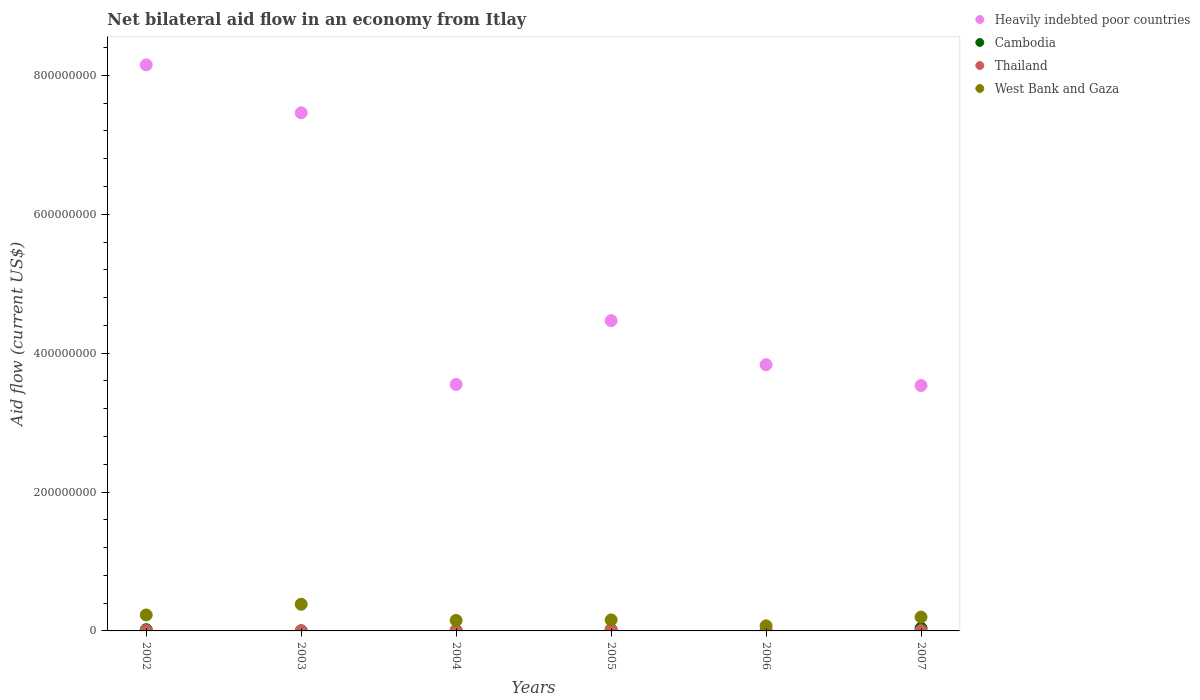How many different coloured dotlines are there?
Give a very brief answer. 4. Is the number of dotlines equal to the number of legend labels?
Ensure brevity in your answer.  Yes. What is the net bilateral aid flow in West Bank and Gaza in 2004?
Give a very brief answer. 1.51e+07. Across all years, what is the maximum net bilateral aid flow in Thailand?
Offer a very short reply. 1.49e+06. In which year was the net bilateral aid flow in Heavily indebted poor countries maximum?
Offer a terse response. 2002. In which year was the net bilateral aid flow in West Bank and Gaza minimum?
Your answer should be very brief. 2006. What is the total net bilateral aid flow in Thailand in the graph?
Your answer should be compact. 4.12e+06. What is the difference between the net bilateral aid flow in Cambodia in 2003 and that in 2006?
Offer a very short reply. -6.00e+04. What is the difference between the net bilateral aid flow in West Bank and Gaza in 2003 and the net bilateral aid flow in Cambodia in 2005?
Ensure brevity in your answer.  3.65e+07. What is the average net bilateral aid flow in West Bank and Gaza per year?
Your response must be concise. 1.99e+07. In the year 2007, what is the difference between the net bilateral aid flow in West Bank and Gaza and net bilateral aid flow in Cambodia?
Keep it short and to the point. 1.60e+07. What is the ratio of the net bilateral aid flow in West Bank and Gaza in 2004 to that in 2006?
Ensure brevity in your answer.  2.07. What is the difference between the highest and the second highest net bilateral aid flow in Heavily indebted poor countries?
Provide a succinct answer. 6.90e+07. What is the difference between the highest and the lowest net bilateral aid flow in Heavily indebted poor countries?
Make the answer very short. 4.62e+08. Is it the case that in every year, the sum of the net bilateral aid flow in Cambodia and net bilateral aid flow in Heavily indebted poor countries  is greater than the sum of net bilateral aid flow in Thailand and net bilateral aid flow in West Bank and Gaza?
Your answer should be very brief. Yes. Is the net bilateral aid flow in Thailand strictly greater than the net bilateral aid flow in Cambodia over the years?
Your response must be concise. No. Is the net bilateral aid flow in Heavily indebted poor countries strictly less than the net bilateral aid flow in Cambodia over the years?
Make the answer very short. No. How many years are there in the graph?
Make the answer very short. 6. Are the values on the major ticks of Y-axis written in scientific E-notation?
Your answer should be very brief. No. Does the graph contain grids?
Your answer should be very brief. No. What is the title of the graph?
Provide a short and direct response. Net bilateral aid flow in an economy from Itlay. What is the label or title of the Y-axis?
Make the answer very short. Aid flow (current US$). What is the Aid flow (current US$) of Heavily indebted poor countries in 2002?
Provide a short and direct response. 8.15e+08. What is the Aid flow (current US$) in Cambodia in 2002?
Ensure brevity in your answer.  1.79e+06. What is the Aid flow (current US$) of Thailand in 2002?
Provide a succinct answer. 5.00e+05. What is the Aid flow (current US$) in West Bank and Gaza in 2002?
Keep it short and to the point. 2.30e+07. What is the Aid flow (current US$) in Heavily indebted poor countries in 2003?
Offer a terse response. 7.46e+08. What is the Aid flow (current US$) in Cambodia in 2003?
Your answer should be very brief. 7.00e+04. What is the Aid flow (current US$) of Thailand in 2003?
Give a very brief answer. 3.10e+05. What is the Aid flow (current US$) of West Bank and Gaza in 2003?
Offer a terse response. 3.84e+07. What is the Aid flow (current US$) in Heavily indebted poor countries in 2004?
Offer a very short reply. 3.55e+08. What is the Aid flow (current US$) of Cambodia in 2004?
Your answer should be very brief. 6.60e+05. What is the Aid flow (current US$) in Thailand in 2004?
Give a very brief answer. 3.20e+05. What is the Aid flow (current US$) of West Bank and Gaza in 2004?
Give a very brief answer. 1.51e+07. What is the Aid flow (current US$) in Heavily indebted poor countries in 2005?
Ensure brevity in your answer.  4.47e+08. What is the Aid flow (current US$) in Cambodia in 2005?
Make the answer very short. 1.92e+06. What is the Aid flow (current US$) in Thailand in 2005?
Give a very brief answer. 1.49e+06. What is the Aid flow (current US$) of West Bank and Gaza in 2005?
Make the answer very short. 1.59e+07. What is the Aid flow (current US$) of Heavily indebted poor countries in 2006?
Keep it short and to the point. 3.83e+08. What is the Aid flow (current US$) of Cambodia in 2006?
Your answer should be compact. 1.30e+05. What is the Aid flow (current US$) in Thailand in 2006?
Ensure brevity in your answer.  1.19e+06. What is the Aid flow (current US$) of West Bank and Gaza in 2006?
Ensure brevity in your answer.  7.32e+06. What is the Aid flow (current US$) of Heavily indebted poor countries in 2007?
Your answer should be very brief. 3.53e+08. What is the Aid flow (current US$) in Cambodia in 2007?
Offer a very short reply. 3.94e+06. What is the Aid flow (current US$) of Thailand in 2007?
Offer a terse response. 3.10e+05. What is the Aid flow (current US$) of West Bank and Gaza in 2007?
Ensure brevity in your answer.  1.99e+07. Across all years, what is the maximum Aid flow (current US$) of Heavily indebted poor countries?
Ensure brevity in your answer.  8.15e+08. Across all years, what is the maximum Aid flow (current US$) of Cambodia?
Offer a very short reply. 3.94e+06. Across all years, what is the maximum Aid flow (current US$) of Thailand?
Your answer should be compact. 1.49e+06. Across all years, what is the maximum Aid flow (current US$) of West Bank and Gaza?
Your response must be concise. 3.84e+07. Across all years, what is the minimum Aid flow (current US$) in Heavily indebted poor countries?
Give a very brief answer. 3.53e+08. Across all years, what is the minimum Aid flow (current US$) in Thailand?
Ensure brevity in your answer.  3.10e+05. Across all years, what is the minimum Aid flow (current US$) in West Bank and Gaza?
Give a very brief answer. 7.32e+06. What is the total Aid flow (current US$) of Heavily indebted poor countries in the graph?
Make the answer very short. 3.10e+09. What is the total Aid flow (current US$) in Cambodia in the graph?
Offer a terse response. 8.51e+06. What is the total Aid flow (current US$) of Thailand in the graph?
Your answer should be very brief. 4.12e+06. What is the total Aid flow (current US$) in West Bank and Gaza in the graph?
Keep it short and to the point. 1.20e+08. What is the difference between the Aid flow (current US$) in Heavily indebted poor countries in 2002 and that in 2003?
Offer a very short reply. 6.90e+07. What is the difference between the Aid flow (current US$) of Cambodia in 2002 and that in 2003?
Make the answer very short. 1.72e+06. What is the difference between the Aid flow (current US$) in West Bank and Gaza in 2002 and that in 2003?
Make the answer very short. -1.54e+07. What is the difference between the Aid flow (current US$) in Heavily indebted poor countries in 2002 and that in 2004?
Ensure brevity in your answer.  4.60e+08. What is the difference between the Aid flow (current US$) of Cambodia in 2002 and that in 2004?
Make the answer very short. 1.13e+06. What is the difference between the Aid flow (current US$) of Thailand in 2002 and that in 2004?
Offer a terse response. 1.80e+05. What is the difference between the Aid flow (current US$) of West Bank and Gaza in 2002 and that in 2004?
Make the answer very short. 7.87e+06. What is the difference between the Aid flow (current US$) of Heavily indebted poor countries in 2002 and that in 2005?
Ensure brevity in your answer.  3.68e+08. What is the difference between the Aid flow (current US$) in Thailand in 2002 and that in 2005?
Keep it short and to the point. -9.90e+05. What is the difference between the Aid flow (current US$) of West Bank and Gaza in 2002 and that in 2005?
Your response must be concise. 7.10e+06. What is the difference between the Aid flow (current US$) of Heavily indebted poor countries in 2002 and that in 2006?
Keep it short and to the point. 4.32e+08. What is the difference between the Aid flow (current US$) in Cambodia in 2002 and that in 2006?
Give a very brief answer. 1.66e+06. What is the difference between the Aid flow (current US$) in Thailand in 2002 and that in 2006?
Offer a terse response. -6.90e+05. What is the difference between the Aid flow (current US$) of West Bank and Gaza in 2002 and that in 2006?
Provide a succinct answer. 1.57e+07. What is the difference between the Aid flow (current US$) in Heavily indebted poor countries in 2002 and that in 2007?
Provide a short and direct response. 4.62e+08. What is the difference between the Aid flow (current US$) of Cambodia in 2002 and that in 2007?
Offer a very short reply. -2.15e+06. What is the difference between the Aid flow (current US$) of West Bank and Gaza in 2002 and that in 2007?
Keep it short and to the point. 3.08e+06. What is the difference between the Aid flow (current US$) in Heavily indebted poor countries in 2003 and that in 2004?
Make the answer very short. 3.91e+08. What is the difference between the Aid flow (current US$) of Cambodia in 2003 and that in 2004?
Your answer should be compact. -5.90e+05. What is the difference between the Aid flow (current US$) of Thailand in 2003 and that in 2004?
Offer a terse response. -10000. What is the difference between the Aid flow (current US$) of West Bank and Gaza in 2003 and that in 2004?
Offer a very short reply. 2.33e+07. What is the difference between the Aid flow (current US$) of Heavily indebted poor countries in 2003 and that in 2005?
Provide a succinct answer. 2.99e+08. What is the difference between the Aid flow (current US$) of Cambodia in 2003 and that in 2005?
Ensure brevity in your answer.  -1.85e+06. What is the difference between the Aid flow (current US$) of Thailand in 2003 and that in 2005?
Provide a succinct answer. -1.18e+06. What is the difference between the Aid flow (current US$) in West Bank and Gaza in 2003 and that in 2005?
Provide a succinct answer. 2.25e+07. What is the difference between the Aid flow (current US$) in Heavily indebted poor countries in 2003 and that in 2006?
Ensure brevity in your answer.  3.63e+08. What is the difference between the Aid flow (current US$) in Thailand in 2003 and that in 2006?
Give a very brief answer. -8.80e+05. What is the difference between the Aid flow (current US$) in West Bank and Gaza in 2003 and that in 2006?
Provide a short and direct response. 3.11e+07. What is the difference between the Aid flow (current US$) of Heavily indebted poor countries in 2003 and that in 2007?
Offer a terse response. 3.93e+08. What is the difference between the Aid flow (current US$) of Cambodia in 2003 and that in 2007?
Keep it short and to the point. -3.87e+06. What is the difference between the Aid flow (current US$) of Thailand in 2003 and that in 2007?
Make the answer very short. 0. What is the difference between the Aid flow (current US$) of West Bank and Gaza in 2003 and that in 2007?
Ensure brevity in your answer.  1.85e+07. What is the difference between the Aid flow (current US$) of Heavily indebted poor countries in 2004 and that in 2005?
Offer a terse response. -9.18e+07. What is the difference between the Aid flow (current US$) of Cambodia in 2004 and that in 2005?
Offer a terse response. -1.26e+06. What is the difference between the Aid flow (current US$) of Thailand in 2004 and that in 2005?
Ensure brevity in your answer.  -1.17e+06. What is the difference between the Aid flow (current US$) in West Bank and Gaza in 2004 and that in 2005?
Offer a terse response. -7.70e+05. What is the difference between the Aid flow (current US$) of Heavily indebted poor countries in 2004 and that in 2006?
Offer a terse response. -2.84e+07. What is the difference between the Aid flow (current US$) in Cambodia in 2004 and that in 2006?
Offer a very short reply. 5.30e+05. What is the difference between the Aid flow (current US$) in Thailand in 2004 and that in 2006?
Your answer should be very brief. -8.70e+05. What is the difference between the Aid flow (current US$) of West Bank and Gaza in 2004 and that in 2006?
Offer a very short reply. 7.80e+06. What is the difference between the Aid flow (current US$) in Heavily indebted poor countries in 2004 and that in 2007?
Your answer should be very brief. 1.54e+06. What is the difference between the Aid flow (current US$) in Cambodia in 2004 and that in 2007?
Provide a short and direct response. -3.28e+06. What is the difference between the Aid flow (current US$) in West Bank and Gaza in 2004 and that in 2007?
Keep it short and to the point. -4.79e+06. What is the difference between the Aid flow (current US$) in Heavily indebted poor countries in 2005 and that in 2006?
Offer a terse response. 6.35e+07. What is the difference between the Aid flow (current US$) in Cambodia in 2005 and that in 2006?
Offer a very short reply. 1.79e+06. What is the difference between the Aid flow (current US$) of West Bank and Gaza in 2005 and that in 2006?
Give a very brief answer. 8.57e+06. What is the difference between the Aid flow (current US$) of Heavily indebted poor countries in 2005 and that in 2007?
Ensure brevity in your answer.  9.34e+07. What is the difference between the Aid flow (current US$) of Cambodia in 2005 and that in 2007?
Your answer should be very brief. -2.02e+06. What is the difference between the Aid flow (current US$) of Thailand in 2005 and that in 2007?
Provide a short and direct response. 1.18e+06. What is the difference between the Aid flow (current US$) in West Bank and Gaza in 2005 and that in 2007?
Offer a very short reply. -4.02e+06. What is the difference between the Aid flow (current US$) of Heavily indebted poor countries in 2006 and that in 2007?
Give a very brief answer. 2.99e+07. What is the difference between the Aid flow (current US$) in Cambodia in 2006 and that in 2007?
Your response must be concise. -3.81e+06. What is the difference between the Aid flow (current US$) of Thailand in 2006 and that in 2007?
Ensure brevity in your answer.  8.80e+05. What is the difference between the Aid flow (current US$) of West Bank and Gaza in 2006 and that in 2007?
Your answer should be compact. -1.26e+07. What is the difference between the Aid flow (current US$) in Heavily indebted poor countries in 2002 and the Aid flow (current US$) in Cambodia in 2003?
Make the answer very short. 8.15e+08. What is the difference between the Aid flow (current US$) of Heavily indebted poor countries in 2002 and the Aid flow (current US$) of Thailand in 2003?
Give a very brief answer. 8.15e+08. What is the difference between the Aid flow (current US$) in Heavily indebted poor countries in 2002 and the Aid flow (current US$) in West Bank and Gaza in 2003?
Provide a short and direct response. 7.77e+08. What is the difference between the Aid flow (current US$) of Cambodia in 2002 and the Aid flow (current US$) of Thailand in 2003?
Provide a short and direct response. 1.48e+06. What is the difference between the Aid flow (current US$) of Cambodia in 2002 and the Aid flow (current US$) of West Bank and Gaza in 2003?
Provide a succinct answer. -3.66e+07. What is the difference between the Aid flow (current US$) of Thailand in 2002 and the Aid flow (current US$) of West Bank and Gaza in 2003?
Offer a very short reply. -3.79e+07. What is the difference between the Aid flow (current US$) of Heavily indebted poor countries in 2002 and the Aid flow (current US$) of Cambodia in 2004?
Your answer should be compact. 8.14e+08. What is the difference between the Aid flow (current US$) in Heavily indebted poor countries in 2002 and the Aid flow (current US$) in Thailand in 2004?
Make the answer very short. 8.15e+08. What is the difference between the Aid flow (current US$) of Heavily indebted poor countries in 2002 and the Aid flow (current US$) of West Bank and Gaza in 2004?
Your answer should be very brief. 8.00e+08. What is the difference between the Aid flow (current US$) in Cambodia in 2002 and the Aid flow (current US$) in Thailand in 2004?
Make the answer very short. 1.47e+06. What is the difference between the Aid flow (current US$) in Cambodia in 2002 and the Aid flow (current US$) in West Bank and Gaza in 2004?
Ensure brevity in your answer.  -1.33e+07. What is the difference between the Aid flow (current US$) of Thailand in 2002 and the Aid flow (current US$) of West Bank and Gaza in 2004?
Your answer should be compact. -1.46e+07. What is the difference between the Aid flow (current US$) in Heavily indebted poor countries in 2002 and the Aid flow (current US$) in Cambodia in 2005?
Offer a terse response. 8.13e+08. What is the difference between the Aid flow (current US$) of Heavily indebted poor countries in 2002 and the Aid flow (current US$) of Thailand in 2005?
Make the answer very short. 8.14e+08. What is the difference between the Aid flow (current US$) of Heavily indebted poor countries in 2002 and the Aid flow (current US$) of West Bank and Gaza in 2005?
Your answer should be very brief. 7.99e+08. What is the difference between the Aid flow (current US$) of Cambodia in 2002 and the Aid flow (current US$) of Thailand in 2005?
Offer a very short reply. 3.00e+05. What is the difference between the Aid flow (current US$) of Cambodia in 2002 and the Aid flow (current US$) of West Bank and Gaza in 2005?
Provide a short and direct response. -1.41e+07. What is the difference between the Aid flow (current US$) of Thailand in 2002 and the Aid flow (current US$) of West Bank and Gaza in 2005?
Provide a short and direct response. -1.54e+07. What is the difference between the Aid flow (current US$) in Heavily indebted poor countries in 2002 and the Aid flow (current US$) in Cambodia in 2006?
Your answer should be compact. 8.15e+08. What is the difference between the Aid flow (current US$) of Heavily indebted poor countries in 2002 and the Aid flow (current US$) of Thailand in 2006?
Provide a short and direct response. 8.14e+08. What is the difference between the Aid flow (current US$) in Heavily indebted poor countries in 2002 and the Aid flow (current US$) in West Bank and Gaza in 2006?
Ensure brevity in your answer.  8.08e+08. What is the difference between the Aid flow (current US$) of Cambodia in 2002 and the Aid flow (current US$) of West Bank and Gaza in 2006?
Offer a terse response. -5.53e+06. What is the difference between the Aid flow (current US$) in Thailand in 2002 and the Aid flow (current US$) in West Bank and Gaza in 2006?
Make the answer very short. -6.82e+06. What is the difference between the Aid flow (current US$) in Heavily indebted poor countries in 2002 and the Aid flow (current US$) in Cambodia in 2007?
Make the answer very short. 8.11e+08. What is the difference between the Aid flow (current US$) in Heavily indebted poor countries in 2002 and the Aid flow (current US$) in Thailand in 2007?
Give a very brief answer. 8.15e+08. What is the difference between the Aid flow (current US$) in Heavily indebted poor countries in 2002 and the Aid flow (current US$) in West Bank and Gaza in 2007?
Provide a short and direct response. 7.95e+08. What is the difference between the Aid flow (current US$) in Cambodia in 2002 and the Aid flow (current US$) in Thailand in 2007?
Give a very brief answer. 1.48e+06. What is the difference between the Aid flow (current US$) of Cambodia in 2002 and the Aid flow (current US$) of West Bank and Gaza in 2007?
Make the answer very short. -1.81e+07. What is the difference between the Aid flow (current US$) of Thailand in 2002 and the Aid flow (current US$) of West Bank and Gaza in 2007?
Your response must be concise. -1.94e+07. What is the difference between the Aid flow (current US$) in Heavily indebted poor countries in 2003 and the Aid flow (current US$) in Cambodia in 2004?
Keep it short and to the point. 7.45e+08. What is the difference between the Aid flow (current US$) of Heavily indebted poor countries in 2003 and the Aid flow (current US$) of Thailand in 2004?
Make the answer very short. 7.46e+08. What is the difference between the Aid flow (current US$) of Heavily indebted poor countries in 2003 and the Aid flow (current US$) of West Bank and Gaza in 2004?
Make the answer very short. 7.31e+08. What is the difference between the Aid flow (current US$) in Cambodia in 2003 and the Aid flow (current US$) in West Bank and Gaza in 2004?
Offer a terse response. -1.50e+07. What is the difference between the Aid flow (current US$) in Thailand in 2003 and the Aid flow (current US$) in West Bank and Gaza in 2004?
Provide a short and direct response. -1.48e+07. What is the difference between the Aid flow (current US$) in Heavily indebted poor countries in 2003 and the Aid flow (current US$) in Cambodia in 2005?
Provide a short and direct response. 7.44e+08. What is the difference between the Aid flow (current US$) in Heavily indebted poor countries in 2003 and the Aid flow (current US$) in Thailand in 2005?
Provide a succinct answer. 7.45e+08. What is the difference between the Aid flow (current US$) of Heavily indebted poor countries in 2003 and the Aid flow (current US$) of West Bank and Gaza in 2005?
Your response must be concise. 7.30e+08. What is the difference between the Aid flow (current US$) in Cambodia in 2003 and the Aid flow (current US$) in Thailand in 2005?
Your response must be concise. -1.42e+06. What is the difference between the Aid flow (current US$) in Cambodia in 2003 and the Aid flow (current US$) in West Bank and Gaza in 2005?
Offer a very short reply. -1.58e+07. What is the difference between the Aid flow (current US$) of Thailand in 2003 and the Aid flow (current US$) of West Bank and Gaza in 2005?
Provide a short and direct response. -1.56e+07. What is the difference between the Aid flow (current US$) of Heavily indebted poor countries in 2003 and the Aid flow (current US$) of Cambodia in 2006?
Your response must be concise. 7.46e+08. What is the difference between the Aid flow (current US$) of Heavily indebted poor countries in 2003 and the Aid flow (current US$) of Thailand in 2006?
Make the answer very short. 7.45e+08. What is the difference between the Aid flow (current US$) of Heavily indebted poor countries in 2003 and the Aid flow (current US$) of West Bank and Gaza in 2006?
Offer a very short reply. 7.39e+08. What is the difference between the Aid flow (current US$) of Cambodia in 2003 and the Aid flow (current US$) of Thailand in 2006?
Your answer should be compact. -1.12e+06. What is the difference between the Aid flow (current US$) in Cambodia in 2003 and the Aid flow (current US$) in West Bank and Gaza in 2006?
Your answer should be very brief. -7.25e+06. What is the difference between the Aid flow (current US$) of Thailand in 2003 and the Aid flow (current US$) of West Bank and Gaza in 2006?
Give a very brief answer. -7.01e+06. What is the difference between the Aid flow (current US$) of Heavily indebted poor countries in 2003 and the Aid flow (current US$) of Cambodia in 2007?
Provide a short and direct response. 7.42e+08. What is the difference between the Aid flow (current US$) of Heavily indebted poor countries in 2003 and the Aid flow (current US$) of Thailand in 2007?
Give a very brief answer. 7.46e+08. What is the difference between the Aid flow (current US$) of Heavily indebted poor countries in 2003 and the Aid flow (current US$) of West Bank and Gaza in 2007?
Your answer should be very brief. 7.26e+08. What is the difference between the Aid flow (current US$) in Cambodia in 2003 and the Aid flow (current US$) in Thailand in 2007?
Your response must be concise. -2.40e+05. What is the difference between the Aid flow (current US$) of Cambodia in 2003 and the Aid flow (current US$) of West Bank and Gaza in 2007?
Ensure brevity in your answer.  -1.98e+07. What is the difference between the Aid flow (current US$) of Thailand in 2003 and the Aid flow (current US$) of West Bank and Gaza in 2007?
Your response must be concise. -1.96e+07. What is the difference between the Aid flow (current US$) in Heavily indebted poor countries in 2004 and the Aid flow (current US$) in Cambodia in 2005?
Keep it short and to the point. 3.53e+08. What is the difference between the Aid flow (current US$) in Heavily indebted poor countries in 2004 and the Aid flow (current US$) in Thailand in 2005?
Offer a very short reply. 3.53e+08. What is the difference between the Aid flow (current US$) in Heavily indebted poor countries in 2004 and the Aid flow (current US$) in West Bank and Gaza in 2005?
Make the answer very short. 3.39e+08. What is the difference between the Aid flow (current US$) in Cambodia in 2004 and the Aid flow (current US$) in Thailand in 2005?
Your answer should be very brief. -8.30e+05. What is the difference between the Aid flow (current US$) of Cambodia in 2004 and the Aid flow (current US$) of West Bank and Gaza in 2005?
Offer a very short reply. -1.52e+07. What is the difference between the Aid flow (current US$) of Thailand in 2004 and the Aid flow (current US$) of West Bank and Gaza in 2005?
Make the answer very short. -1.56e+07. What is the difference between the Aid flow (current US$) of Heavily indebted poor countries in 2004 and the Aid flow (current US$) of Cambodia in 2006?
Provide a succinct answer. 3.55e+08. What is the difference between the Aid flow (current US$) of Heavily indebted poor countries in 2004 and the Aid flow (current US$) of Thailand in 2006?
Give a very brief answer. 3.54e+08. What is the difference between the Aid flow (current US$) of Heavily indebted poor countries in 2004 and the Aid flow (current US$) of West Bank and Gaza in 2006?
Your answer should be compact. 3.48e+08. What is the difference between the Aid flow (current US$) in Cambodia in 2004 and the Aid flow (current US$) in Thailand in 2006?
Ensure brevity in your answer.  -5.30e+05. What is the difference between the Aid flow (current US$) of Cambodia in 2004 and the Aid flow (current US$) of West Bank and Gaza in 2006?
Offer a very short reply. -6.66e+06. What is the difference between the Aid flow (current US$) in Thailand in 2004 and the Aid flow (current US$) in West Bank and Gaza in 2006?
Provide a succinct answer. -7.00e+06. What is the difference between the Aid flow (current US$) in Heavily indebted poor countries in 2004 and the Aid flow (current US$) in Cambodia in 2007?
Provide a succinct answer. 3.51e+08. What is the difference between the Aid flow (current US$) in Heavily indebted poor countries in 2004 and the Aid flow (current US$) in Thailand in 2007?
Provide a short and direct response. 3.55e+08. What is the difference between the Aid flow (current US$) of Heavily indebted poor countries in 2004 and the Aid flow (current US$) of West Bank and Gaza in 2007?
Your answer should be compact. 3.35e+08. What is the difference between the Aid flow (current US$) in Cambodia in 2004 and the Aid flow (current US$) in West Bank and Gaza in 2007?
Your answer should be compact. -1.92e+07. What is the difference between the Aid flow (current US$) of Thailand in 2004 and the Aid flow (current US$) of West Bank and Gaza in 2007?
Keep it short and to the point. -1.96e+07. What is the difference between the Aid flow (current US$) in Heavily indebted poor countries in 2005 and the Aid flow (current US$) in Cambodia in 2006?
Offer a terse response. 4.47e+08. What is the difference between the Aid flow (current US$) of Heavily indebted poor countries in 2005 and the Aid flow (current US$) of Thailand in 2006?
Your answer should be compact. 4.46e+08. What is the difference between the Aid flow (current US$) in Heavily indebted poor countries in 2005 and the Aid flow (current US$) in West Bank and Gaza in 2006?
Your answer should be compact. 4.39e+08. What is the difference between the Aid flow (current US$) in Cambodia in 2005 and the Aid flow (current US$) in Thailand in 2006?
Your response must be concise. 7.30e+05. What is the difference between the Aid flow (current US$) of Cambodia in 2005 and the Aid flow (current US$) of West Bank and Gaza in 2006?
Ensure brevity in your answer.  -5.40e+06. What is the difference between the Aid flow (current US$) in Thailand in 2005 and the Aid flow (current US$) in West Bank and Gaza in 2006?
Ensure brevity in your answer.  -5.83e+06. What is the difference between the Aid flow (current US$) of Heavily indebted poor countries in 2005 and the Aid flow (current US$) of Cambodia in 2007?
Your answer should be very brief. 4.43e+08. What is the difference between the Aid flow (current US$) of Heavily indebted poor countries in 2005 and the Aid flow (current US$) of Thailand in 2007?
Give a very brief answer. 4.46e+08. What is the difference between the Aid flow (current US$) in Heavily indebted poor countries in 2005 and the Aid flow (current US$) in West Bank and Gaza in 2007?
Your response must be concise. 4.27e+08. What is the difference between the Aid flow (current US$) in Cambodia in 2005 and the Aid flow (current US$) in Thailand in 2007?
Provide a short and direct response. 1.61e+06. What is the difference between the Aid flow (current US$) in Cambodia in 2005 and the Aid flow (current US$) in West Bank and Gaza in 2007?
Ensure brevity in your answer.  -1.80e+07. What is the difference between the Aid flow (current US$) of Thailand in 2005 and the Aid flow (current US$) of West Bank and Gaza in 2007?
Your answer should be compact. -1.84e+07. What is the difference between the Aid flow (current US$) in Heavily indebted poor countries in 2006 and the Aid flow (current US$) in Cambodia in 2007?
Provide a succinct answer. 3.79e+08. What is the difference between the Aid flow (current US$) of Heavily indebted poor countries in 2006 and the Aid flow (current US$) of Thailand in 2007?
Your response must be concise. 3.83e+08. What is the difference between the Aid flow (current US$) in Heavily indebted poor countries in 2006 and the Aid flow (current US$) in West Bank and Gaza in 2007?
Keep it short and to the point. 3.63e+08. What is the difference between the Aid flow (current US$) in Cambodia in 2006 and the Aid flow (current US$) in Thailand in 2007?
Your answer should be very brief. -1.80e+05. What is the difference between the Aid flow (current US$) of Cambodia in 2006 and the Aid flow (current US$) of West Bank and Gaza in 2007?
Give a very brief answer. -1.98e+07. What is the difference between the Aid flow (current US$) of Thailand in 2006 and the Aid flow (current US$) of West Bank and Gaza in 2007?
Keep it short and to the point. -1.87e+07. What is the average Aid flow (current US$) in Heavily indebted poor countries per year?
Provide a short and direct response. 5.17e+08. What is the average Aid flow (current US$) in Cambodia per year?
Your answer should be compact. 1.42e+06. What is the average Aid flow (current US$) in Thailand per year?
Your answer should be compact. 6.87e+05. What is the average Aid flow (current US$) of West Bank and Gaza per year?
Give a very brief answer. 1.99e+07. In the year 2002, what is the difference between the Aid flow (current US$) in Heavily indebted poor countries and Aid flow (current US$) in Cambodia?
Provide a succinct answer. 8.13e+08. In the year 2002, what is the difference between the Aid flow (current US$) in Heavily indebted poor countries and Aid flow (current US$) in Thailand?
Provide a succinct answer. 8.15e+08. In the year 2002, what is the difference between the Aid flow (current US$) of Heavily indebted poor countries and Aid flow (current US$) of West Bank and Gaza?
Your response must be concise. 7.92e+08. In the year 2002, what is the difference between the Aid flow (current US$) in Cambodia and Aid flow (current US$) in Thailand?
Give a very brief answer. 1.29e+06. In the year 2002, what is the difference between the Aid flow (current US$) in Cambodia and Aid flow (current US$) in West Bank and Gaza?
Your answer should be compact. -2.12e+07. In the year 2002, what is the difference between the Aid flow (current US$) of Thailand and Aid flow (current US$) of West Bank and Gaza?
Give a very brief answer. -2.25e+07. In the year 2003, what is the difference between the Aid flow (current US$) of Heavily indebted poor countries and Aid flow (current US$) of Cambodia?
Offer a very short reply. 7.46e+08. In the year 2003, what is the difference between the Aid flow (current US$) in Heavily indebted poor countries and Aid flow (current US$) in Thailand?
Ensure brevity in your answer.  7.46e+08. In the year 2003, what is the difference between the Aid flow (current US$) in Heavily indebted poor countries and Aid flow (current US$) in West Bank and Gaza?
Provide a succinct answer. 7.08e+08. In the year 2003, what is the difference between the Aid flow (current US$) in Cambodia and Aid flow (current US$) in Thailand?
Provide a short and direct response. -2.40e+05. In the year 2003, what is the difference between the Aid flow (current US$) in Cambodia and Aid flow (current US$) in West Bank and Gaza?
Your answer should be compact. -3.83e+07. In the year 2003, what is the difference between the Aid flow (current US$) in Thailand and Aid flow (current US$) in West Bank and Gaza?
Provide a succinct answer. -3.81e+07. In the year 2004, what is the difference between the Aid flow (current US$) in Heavily indebted poor countries and Aid flow (current US$) in Cambodia?
Your answer should be very brief. 3.54e+08. In the year 2004, what is the difference between the Aid flow (current US$) of Heavily indebted poor countries and Aid flow (current US$) of Thailand?
Your answer should be compact. 3.55e+08. In the year 2004, what is the difference between the Aid flow (current US$) of Heavily indebted poor countries and Aid flow (current US$) of West Bank and Gaza?
Offer a very short reply. 3.40e+08. In the year 2004, what is the difference between the Aid flow (current US$) in Cambodia and Aid flow (current US$) in West Bank and Gaza?
Offer a terse response. -1.45e+07. In the year 2004, what is the difference between the Aid flow (current US$) in Thailand and Aid flow (current US$) in West Bank and Gaza?
Offer a terse response. -1.48e+07. In the year 2005, what is the difference between the Aid flow (current US$) of Heavily indebted poor countries and Aid flow (current US$) of Cambodia?
Offer a terse response. 4.45e+08. In the year 2005, what is the difference between the Aid flow (current US$) in Heavily indebted poor countries and Aid flow (current US$) in Thailand?
Offer a terse response. 4.45e+08. In the year 2005, what is the difference between the Aid flow (current US$) in Heavily indebted poor countries and Aid flow (current US$) in West Bank and Gaza?
Offer a terse response. 4.31e+08. In the year 2005, what is the difference between the Aid flow (current US$) in Cambodia and Aid flow (current US$) in West Bank and Gaza?
Offer a terse response. -1.40e+07. In the year 2005, what is the difference between the Aid flow (current US$) of Thailand and Aid flow (current US$) of West Bank and Gaza?
Your answer should be compact. -1.44e+07. In the year 2006, what is the difference between the Aid flow (current US$) of Heavily indebted poor countries and Aid flow (current US$) of Cambodia?
Provide a short and direct response. 3.83e+08. In the year 2006, what is the difference between the Aid flow (current US$) in Heavily indebted poor countries and Aid flow (current US$) in Thailand?
Your answer should be very brief. 3.82e+08. In the year 2006, what is the difference between the Aid flow (current US$) in Heavily indebted poor countries and Aid flow (current US$) in West Bank and Gaza?
Provide a succinct answer. 3.76e+08. In the year 2006, what is the difference between the Aid flow (current US$) of Cambodia and Aid flow (current US$) of Thailand?
Offer a terse response. -1.06e+06. In the year 2006, what is the difference between the Aid flow (current US$) of Cambodia and Aid flow (current US$) of West Bank and Gaza?
Your response must be concise. -7.19e+06. In the year 2006, what is the difference between the Aid flow (current US$) of Thailand and Aid flow (current US$) of West Bank and Gaza?
Provide a short and direct response. -6.13e+06. In the year 2007, what is the difference between the Aid flow (current US$) of Heavily indebted poor countries and Aid flow (current US$) of Cambodia?
Give a very brief answer. 3.49e+08. In the year 2007, what is the difference between the Aid flow (current US$) in Heavily indebted poor countries and Aid flow (current US$) in Thailand?
Offer a terse response. 3.53e+08. In the year 2007, what is the difference between the Aid flow (current US$) of Heavily indebted poor countries and Aid flow (current US$) of West Bank and Gaza?
Offer a terse response. 3.33e+08. In the year 2007, what is the difference between the Aid flow (current US$) of Cambodia and Aid flow (current US$) of Thailand?
Provide a short and direct response. 3.63e+06. In the year 2007, what is the difference between the Aid flow (current US$) of Cambodia and Aid flow (current US$) of West Bank and Gaza?
Make the answer very short. -1.60e+07. In the year 2007, what is the difference between the Aid flow (current US$) of Thailand and Aid flow (current US$) of West Bank and Gaza?
Make the answer very short. -1.96e+07. What is the ratio of the Aid flow (current US$) in Heavily indebted poor countries in 2002 to that in 2003?
Offer a very short reply. 1.09. What is the ratio of the Aid flow (current US$) in Cambodia in 2002 to that in 2003?
Provide a short and direct response. 25.57. What is the ratio of the Aid flow (current US$) of Thailand in 2002 to that in 2003?
Provide a succinct answer. 1.61. What is the ratio of the Aid flow (current US$) in West Bank and Gaza in 2002 to that in 2003?
Offer a terse response. 0.6. What is the ratio of the Aid flow (current US$) of Heavily indebted poor countries in 2002 to that in 2004?
Give a very brief answer. 2.3. What is the ratio of the Aid flow (current US$) in Cambodia in 2002 to that in 2004?
Provide a short and direct response. 2.71. What is the ratio of the Aid flow (current US$) of Thailand in 2002 to that in 2004?
Ensure brevity in your answer.  1.56. What is the ratio of the Aid flow (current US$) in West Bank and Gaza in 2002 to that in 2004?
Make the answer very short. 1.52. What is the ratio of the Aid flow (current US$) of Heavily indebted poor countries in 2002 to that in 2005?
Make the answer very short. 1.82. What is the ratio of the Aid flow (current US$) of Cambodia in 2002 to that in 2005?
Ensure brevity in your answer.  0.93. What is the ratio of the Aid flow (current US$) of Thailand in 2002 to that in 2005?
Offer a very short reply. 0.34. What is the ratio of the Aid flow (current US$) in West Bank and Gaza in 2002 to that in 2005?
Provide a succinct answer. 1.45. What is the ratio of the Aid flow (current US$) in Heavily indebted poor countries in 2002 to that in 2006?
Offer a very short reply. 2.13. What is the ratio of the Aid flow (current US$) in Cambodia in 2002 to that in 2006?
Provide a succinct answer. 13.77. What is the ratio of the Aid flow (current US$) of Thailand in 2002 to that in 2006?
Your answer should be compact. 0.42. What is the ratio of the Aid flow (current US$) of West Bank and Gaza in 2002 to that in 2006?
Keep it short and to the point. 3.14. What is the ratio of the Aid flow (current US$) in Heavily indebted poor countries in 2002 to that in 2007?
Your answer should be compact. 2.31. What is the ratio of the Aid flow (current US$) of Cambodia in 2002 to that in 2007?
Give a very brief answer. 0.45. What is the ratio of the Aid flow (current US$) of Thailand in 2002 to that in 2007?
Give a very brief answer. 1.61. What is the ratio of the Aid flow (current US$) in West Bank and Gaza in 2002 to that in 2007?
Offer a terse response. 1.15. What is the ratio of the Aid flow (current US$) of Heavily indebted poor countries in 2003 to that in 2004?
Provide a succinct answer. 2.1. What is the ratio of the Aid flow (current US$) in Cambodia in 2003 to that in 2004?
Make the answer very short. 0.11. What is the ratio of the Aid flow (current US$) in Thailand in 2003 to that in 2004?
Give a very brief answer. 0.97. What is the ratio of the Aid flow (current US$) of West Bank and Gaza in 2003 to that in 2004?
Keep it short and to the point. 2.54. What is the ratio of the Aid flow (current US$) of Heavily indebted poor countries in 2003 to that in 2005?
Your answer should be very brief. 1.67. What is the ratio of the Aid flow (current US$) of Cambodia in 2003 to that in 2005?
Provide a short and direct response. 0.04. What is the ratio of the Aid flow (current US$) in Thailand in 2003 to that in 2005?
Offer a terse response. 0.21. What is the ratio of the Aid flow (current US$) in West Bank and Gaza in 2003 to that in 2005?
Ensure brevity in your answer.  2.42. What is the ratio of the Aid flow (current US$) in Heavily indebted poor countries in 2003 to that in 2006?
Give a very brief answer. 1.95. What is the ratio of the Aid flow (current US$) in Cambodia in 2003 to that in 2006?
Offer a very short reply. 0.54. What is the ratio of the Aid flow (current US$) of Thailand in 2003 to that in 2006?
Your response must be concise. 0.26. What is the ratio of the Aid flow (current US$) of West Bank and Gaza in 2003 to that in 2006?
Ensure brevity in your answer.  5.24. What is the ratio of the Aid flow (current US$) in Heavily indebted poor countries in 2003 to that in 2007?
Provide a short and direct response. 2.11. What is the ratio of the Aid flow (current US$) in Cambodia in 2003 to that in 2007?
Ensure brevity in your answer.  0.02. What is the ratio of the Aid flow (current US$) in West Bank and Gaza in 2003 to that in 2007?
Your answer should be compact. 1.93. What is the ratio of the Aid flow (current US$) in Heavily indebted poor countries in 2004 to that in 2005?
Keep it short and to the point. 0.79. What is the ratio of the Aid flow (current US$) in Cambodia in 2004 to that in 2005?
Make the answer very short. 0.34. What is the ratio of the Aid flow (current US$) in Thailand in 2004 to that in 2005?
Offer a terse response. 0.21. What is the ratio of the Aid flow (current US$) in West Bank and Gaza in 2004 to that in 2005?
Make the answer very short. 0.95. What is the ratio of the Aid flow (current US$) in Heavily indebted poor countries in 2004 to that in 2006?
Your answer should be compact. 0.93. What is the ratio of the Aid flow (current US$) of Cambodia in 2004 to that in 2006?
Your answer should be very brief. 5.08. What is the ratio of the Aid flow (current US$) of Thailand in 2004 to that in 2006?
Provide a succinct answer. 0.27. What is the ratio of the Aid flow (current US$) of West Bank and Gaza in 2004 to that in 2006?
Keep it short and to the point. 2.07. What is the ratio of the Aid flow (current US$) of Heavily indebted poor countries in 2004 to that in 2007?
Keep it short and to the point. 1. What is the ratio of the Aid flow (current US$) in Cambodia in 2004 to that in 2007?
Provide a succinct answer. 0.17. What is the ratio of the Aid flow (current US$) in Thailand in 2004 to that in 2007?
Make the answer very short. 1.03. What is the ratio of the Aid flow (current US$) of West Bank and Gaza in 2004 to that in 2007?
Keep it short and to the point. 0.76. What is the ratio of the Aid flow (current US$) of Heavily indebted poor countries in 2005 to that in 2006?
Your answer should be compact. 1.17. What is the ratio of the Aid flow (current US$) of Cambodia in 2005 to that in 2006?
Provide a succinct answer. 14.77. What is the ratio of the Aid flow (current US$) of Thailand in 2005 to that in 2006?
Your answer should be compact. 1.25. What is the ratio of the Aid flow (current US$) in West Bank and Gaza in 2005 to that in 2006?
Your answer should be compact. 2.17. What is the ratio of the Aid flow (current US$) in Heavily indebted poor countries in 2005 to that in 2007?
Ensure brevity in your answer.  1.26. What is the ratio of the Aid flow (current US$) of Cambodia in 2005 to that in 2007?
Give a very brief answer. 0.49. What is the ratio of the Aid flow (current US$) in Thailand in 2005 to that in 2007?
Provide a succinct answer. 4.81. What is the ratio of the Aid flow (current US$) in West Bank and Gaza in 2005 to that in 2007?
Ensure brevity in your answer.  0.8. What is the ratio of the Aid flow (current US$) in Heavily indebted poor countries in 2006 to that in 2007?
Your answer should be compact. 1.08. What is the ratio of the Aid flow (current US$) of Cambodia in 2006 to that in 2007?
Keep it short and to the point. 0.03. What is the ratio of the Aid flow (current US$) in Thailand in 2006 to that in 2007?
Provide a succinct answer. 3.84. What is the ratio of the Aid flow (current US$) of West Bank and Gaza in 2006 to that in 2007?
Keep it short and to the point. 0.37. What is the difference between the highest and the second highest Aid flow (current US$) of Heavily indebted poor countries?
Keep it short and to the point. 6.90e+07. What is the difference between the highest and the second highest Aid flow (current US$) in Cambodia?
Offer a very short reply. 2.02e+06. What is the difference between the highest and the second highest Aid flow (current US$) in West Bank and Gaza?
Offer a very short reply. 1.54e+07. What is the difference between the highest and the lowest Aid flow (current US$) of Heavily indebted poor countries?
Your response must be concise. 4.62e+08. What is the difference between the highest and the lowest Aid flow (current US$) in Cambodia?
Ensure brevity in your answer.  3.87e+06. What is the difference between the highest and the lowest Aid flow (current US$) of Thailand?
Provide a succinct answer. 1.18e+06. What is the difference between the highest and the lowest Aid flow (current US$) of West Bank and Gaza?
Your response must be concise. 3.11e+07. 